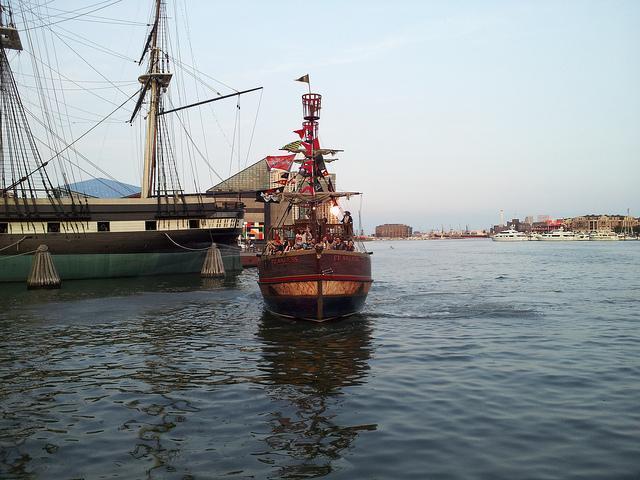How many boats are in the picture?
Give a very brief answer. 2. How many sandwiches with orange paste are in the picture?
Give a very brief answer. 0. 